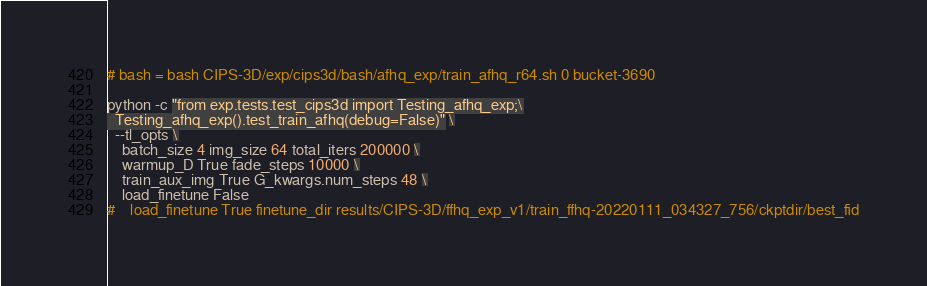Convert code to text. <code><loc_0><loc_0><loc_500><loc_500><_Bash_># bash = bash CIPS-3D/exp/cips3d/bash/afhq_exp/train_afhq_r64.sh 0 bucket-3690

python -c "from exp.tests.test_cips3d import Testing_afhq_exp;\
  Testing_afhq_exp().test_train_afhq(debug=False)" \
  --tl_opts \
    batch_size 4 img_size 64 total_iters 200000 \
    warmup_D True fade_steps 10000 \
    train_aux_img True G_kwargs.num_steps 48 \
    load_finetune False
#    load_finetune True finetune_dir results/CIPS-3D/ffhq_exp_v1/train_ffhq-20220111_034327_756/ckptdir/best_fid












</code> 